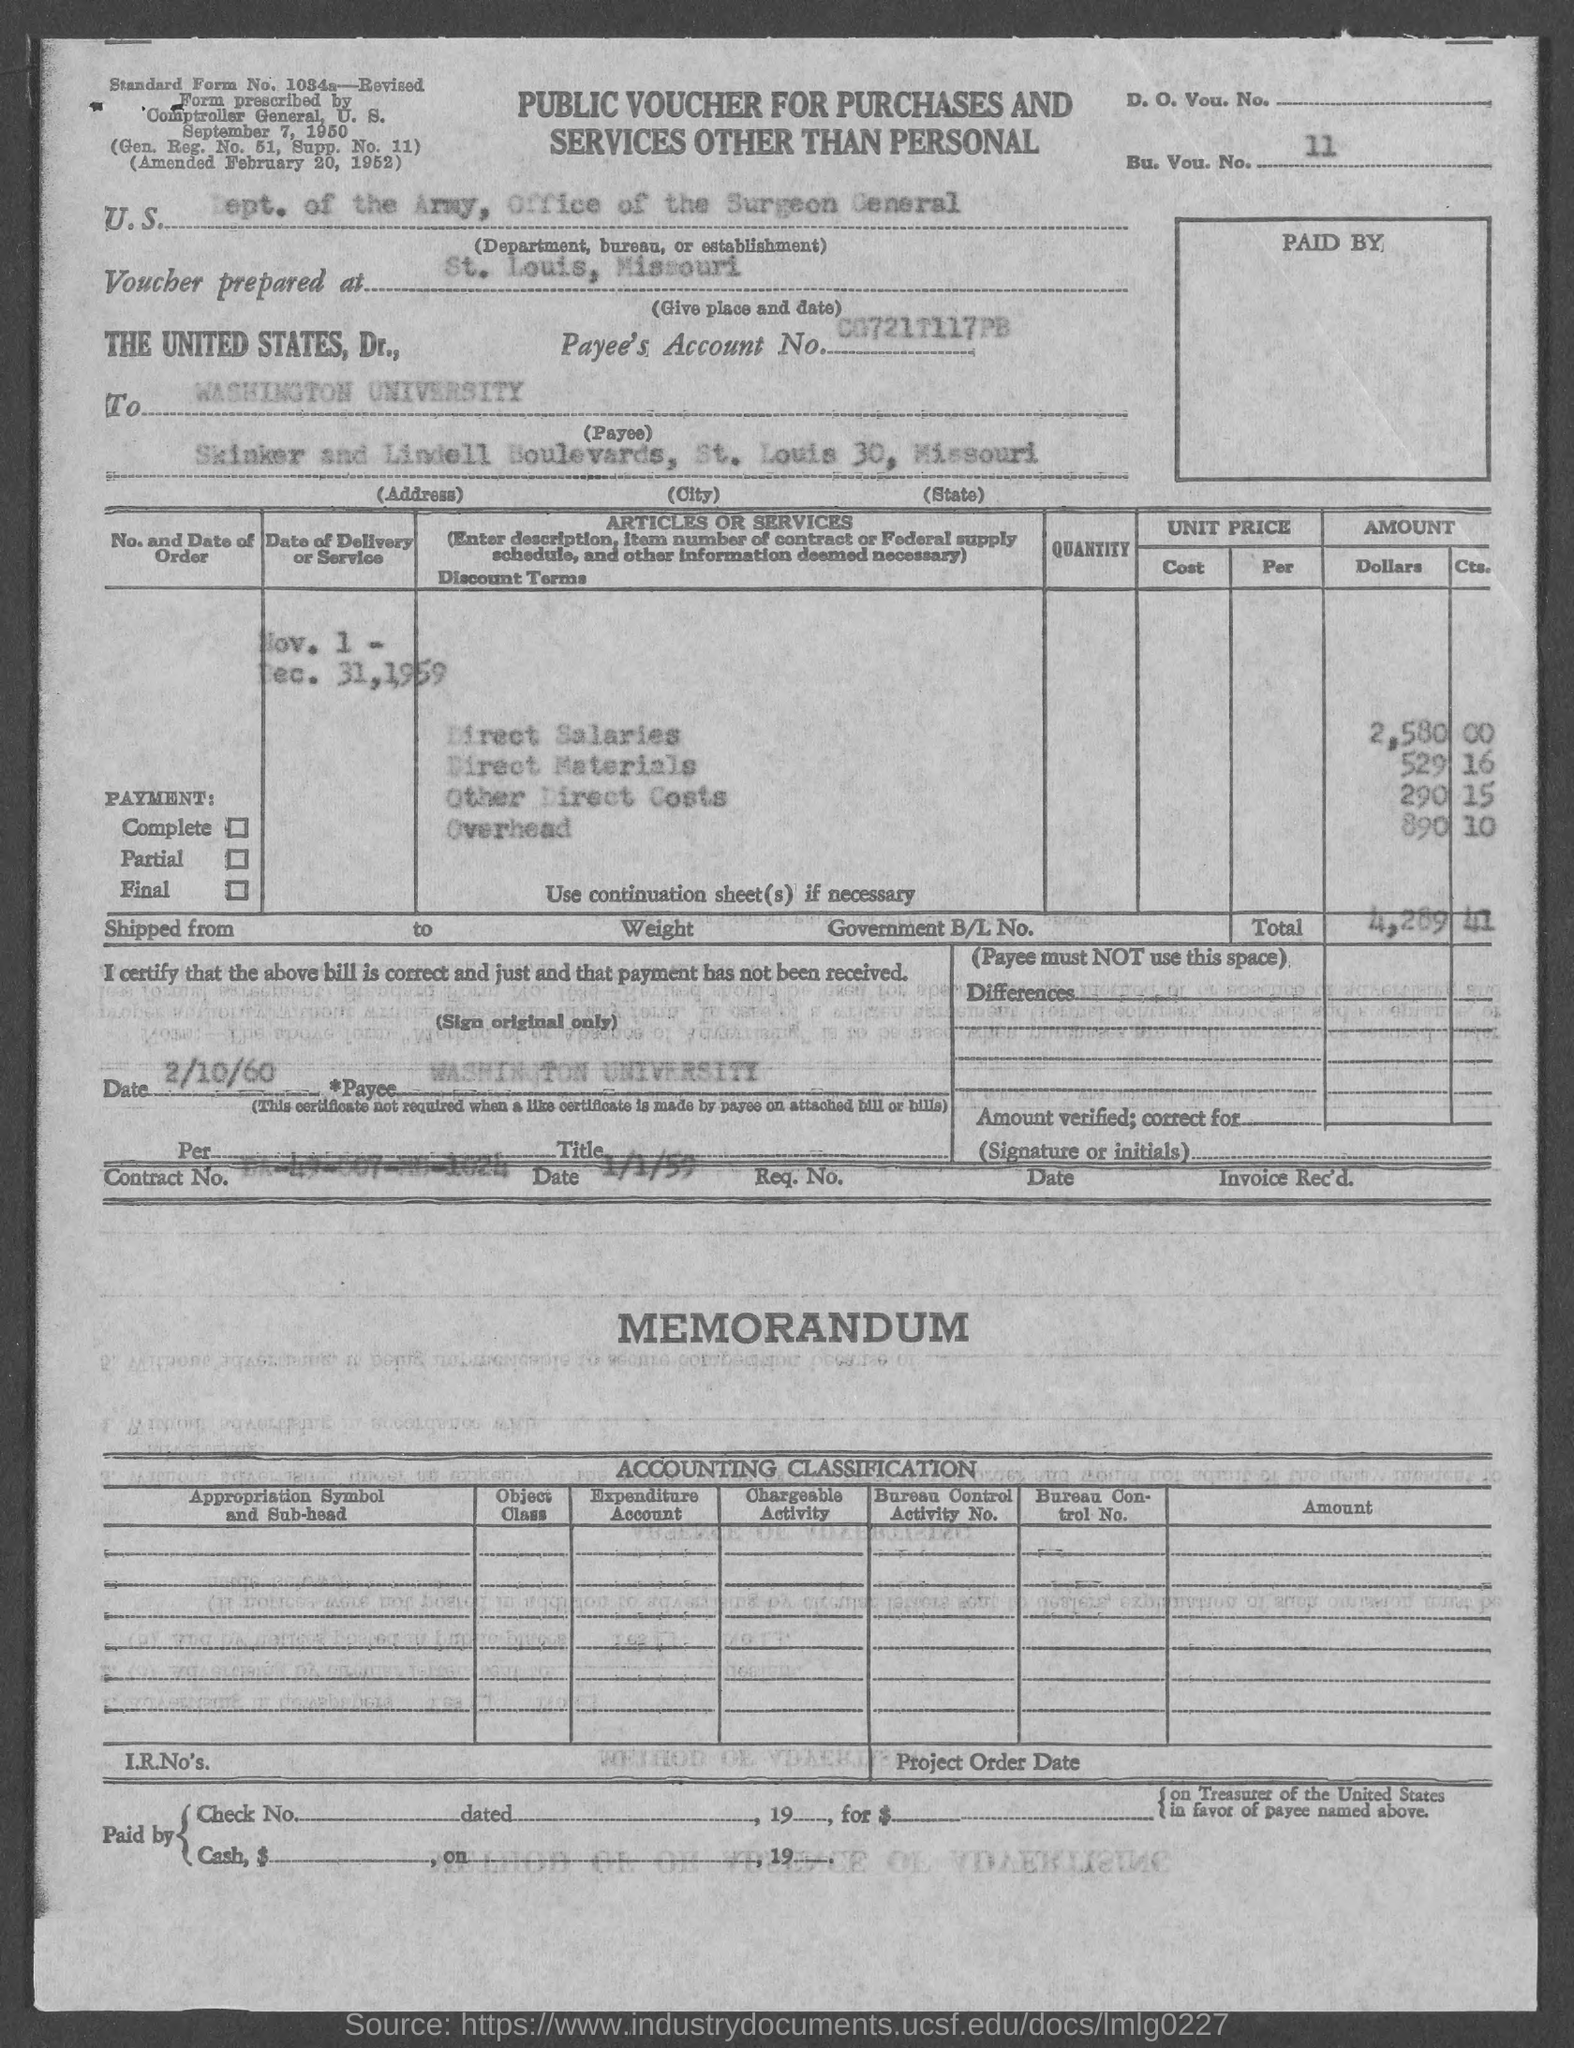Specify some key components in this picture. The overhead cost mentioned in the voucher is 890, with an additional 10% service charge. The payee name mentioned in the voucher is "Washington University. The direct salaries cost mentioned in the voucher is 2,580.00. The voucher indicates that the U.S. Department, Bureau, or Establishment is the Department of the Army, Office of the Surgeon General. The total voucher amount mentioned in the document is Rs. 4,289.41. 